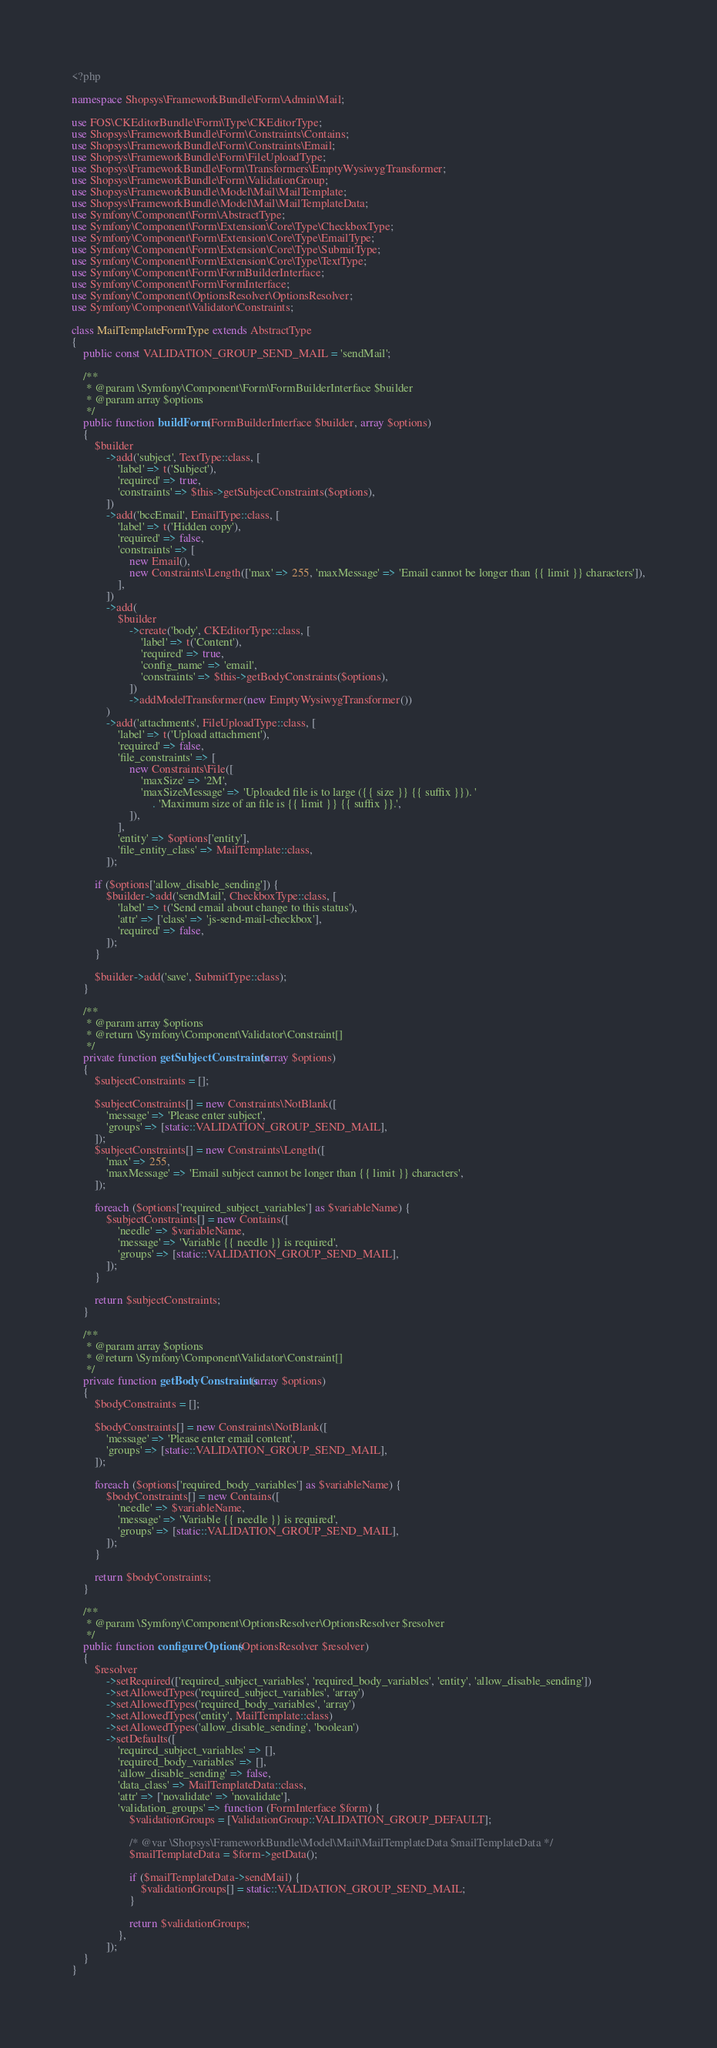Convert code to text. <code><loc_0><loc_0><loc_500><loc_500><_PHP_><?php

namespace Shopsys\FrameworkBundle\Form\Admin\Mail;

use FOS\CKEditorBundle\Form\Type\CKEditorType;
use Shopsys\FrameworkBundle\Form\Constraints\Contains;
use Shopsys\FrameworkBundle\Form\Constraints\Email;
use Shopsys\FrameworkBundle\Form\FileUploadType;
use Shopsys\FrameworkBundle\Form\Transformers\EmptyWysiwygTransformer;
use Shopsys\FrameworkBundle\Form\ValidationGroup;
use Shopsys\FrameworkBundle\Model\Mail\MailTemplate;
use Shopsys\FrameworkBundle\Model\Mail\MailTemplateData;
use Symfony\Component\Form\AbstractType;
use Symfony\Component\Form\Extension\Core\Type\CheckboxType;
use Symfony\Component\Form\Extension\Core\Type\EmailType;
use Symfony\Component\Form\Extension\Core\Type\SubmitType;
use Symfony\Component\Form\Extension\Core\Type\TextType;
use Symfony\Component\Form\FormBuilderInterface;
use Symfony\Component\Form\FormInterface;
use Symfony\Component\OptionsResolver\OptionsResolver;
use Symfony\Component\Validator\Constraints;

class MailTemplateFormType extends AbstractType
{
    public const VALIDATION_GROUP_SEND_MAIL = 'sendMail';

    /**
     * @param \Symfony\Component\Form\FormBuilderInterface $builder
     * @param array $options
     */
    public function buildForm(FormBuilderInterface $builder, array $options)
    {
        $builder
            ->add('subject', TextType::class, [
                'label' => t('Subject'),
                'required' => true,
                'constraints' => $this->getSubjectConstraints($options),
            ])
            ->add('bccEmail', EmailType::class, [
                'label' => t('Hidden copy'),
                'required' => false,
                'constraints' => [
                    new Email(),
                    new Constraints\Length(['max' => 255, 'maxMessage' => 'Email cannot be longer than {{ limit }} characters']),
                ],
            ])
            ->add(
                $builder
                    ->create('body', CKEditorType::class, [
                        'label' => t('Content'),
                        'required' => true,
                        'config_name' => 'email',
                        'constraints' => $this->getBodyConstraints($options),
                    ])
                    ->addModelTransformer(new EmptyWysiwygTransformer())
            )
            ->add('attachments', FileUploadType::class, [
                'label' => t('Upload attachment'),
                'required' => false,
                'file_constraints' => [
                    new Constraints\File([
                        'maxSize' => '2M',
                        'maxSizeMessage' => 'Uploaded file is to large ({{ size }} {{ suffix }}). '
                            . 'Maximum size of an file is {{ limit }} {{ suffix }}.',
                    ]),
                ],
                'entity' => $options['entity'],
                'file_entity_class' => MailTemplate::class,
            ]);

        if ($options['allow_disable_sending']) {
            $builder->add('sendMail', CheckboxType::class, [
                'label' => t('Send email about change to this status'),
                'attr' => ['class' => 'js-send-mail-checkbox'],
                'required' => false,
            ]);
        }

        $builder->add('save', SubmitType::class);
    }

    /**
     * @param array $options
     * @return \Symfony\Component\Validator\Constraint[]
     */
    private function getSubjectConstraints(array $options)
    {
        $subjectConstraints = [];

        $subjectConstraints[] = new Constraints\NotBlank([
            'message' => 'Please enter subject',
            'groups' => [static::VALIDATION_GROUP_SEND_MAIL],
        ]);
        $subjectConstraints[] = new Constraints\Length([
            'max' => 255,
            'maxMessage' => 'Email subject cannot be longer than {{ limit }} characters',
        ]);

        foreach ($options['required_subject_variables'] as $variableName) {
            $subjectConstraints[] = new Contains([
                'needle' => $variableName,
                'message' => 'Variable {{ needle }} is required',
                'groups' => [static::VALIDATION_GROUP_SEND_MAIL],
            ]);
        }

        return $subjectConstraints;
    }

    /**
     * @param array $options
     * @return \Symfony\Component\Validator\Constraint[]
     */
    private function getBodyConstraints(array $options)
    {
        $bodyConstraints = [];

        $bodyConstraints[] = new Constraints\NotBlank([
            'message' => 'Please enter email content',
            'groups' => [static::VALIDATION_GROUP_SEND_MAIL],
        ]);

        foreach ($options['required_body_variables'] as $variableName) {
            $bodyConstraints[] = new Contains([
                'needle' => $variableName,
                'message' => 'Variable {{ needle }} is required',
                'groups' => [static::VALIDATION_GROUP_SEND_MAIL],
            ]);
        }

        return $bodyConstraints;
    }

    /**
     * @param \Symfony\Component\OptionsResolver\OptionsResolver $resolver
     */
    public function configureOptions(OptionsResolver $resolver)
    {
        $resolver
            ->setRequired(['required_subject_variables', 'required_body_variables', 'entity', 'allow_disable_sending'])
            ->setAllowedTypes('required_subject_variables', 'array')
            ->setAllowedTypes('required_body_variables', 'array')
            ->setAllowedTypes('entity', MailTemplate::class)
            ->setAllowedTypes('allow_disable_sending', 'boolean')
            ->setDefaults([
                'required_subject_variables' => [],
                'required_body_variables' => [],
                'allow_disable_sending' => false,
                'data_class' => MailTemplateData::class,
                'attr' => ['novalidate' => 'novalidate'],
                'validation_groups' => function (FormInterface $form) {
                    $validationGroups = [ValidationGroup::VALIDATION_GROUP_DEFAULT];

                    /* @var \Shopsys\FrameworkBundle\Model\Mail\MailTemplateData $mailTemplateData */
                    $mailTemplateData = $form->getData();

                    if ($mailTemplateData->sendMail) {
                        $validationGroups[] = static::VALIDATION_GROUP_SEND_MAIL;
                    }

                    return $validationGroups;
                },
            ]);
    }
}
</code> 